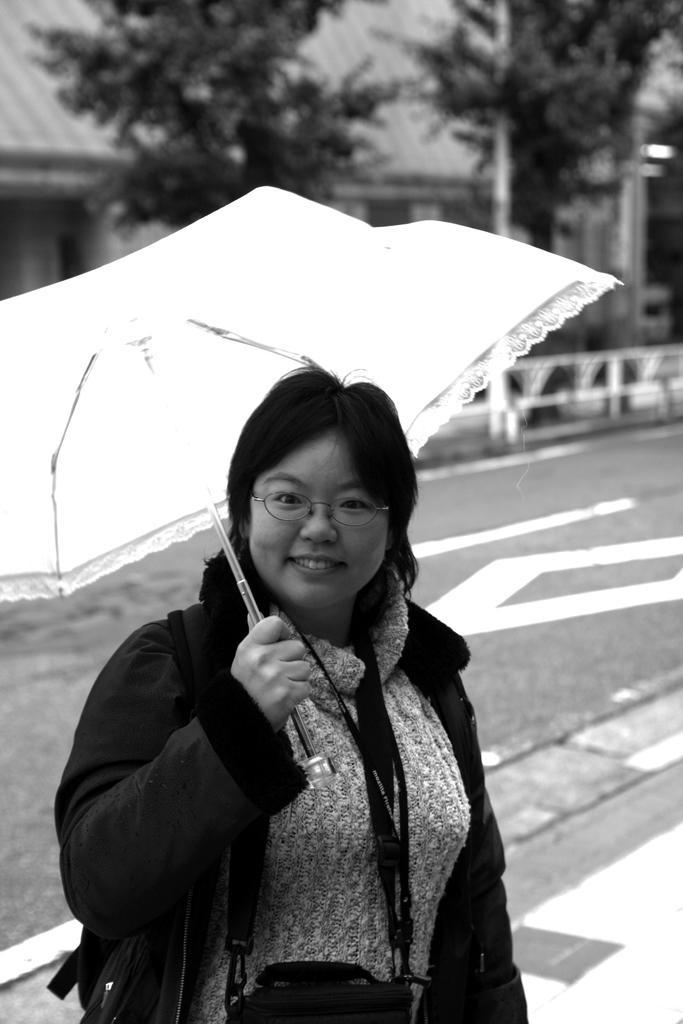How would you summarize this image in a sentence or two? In this image I can see a person standing and holding an umbrella, background I can see trees and buildings and the image is in black and white. 